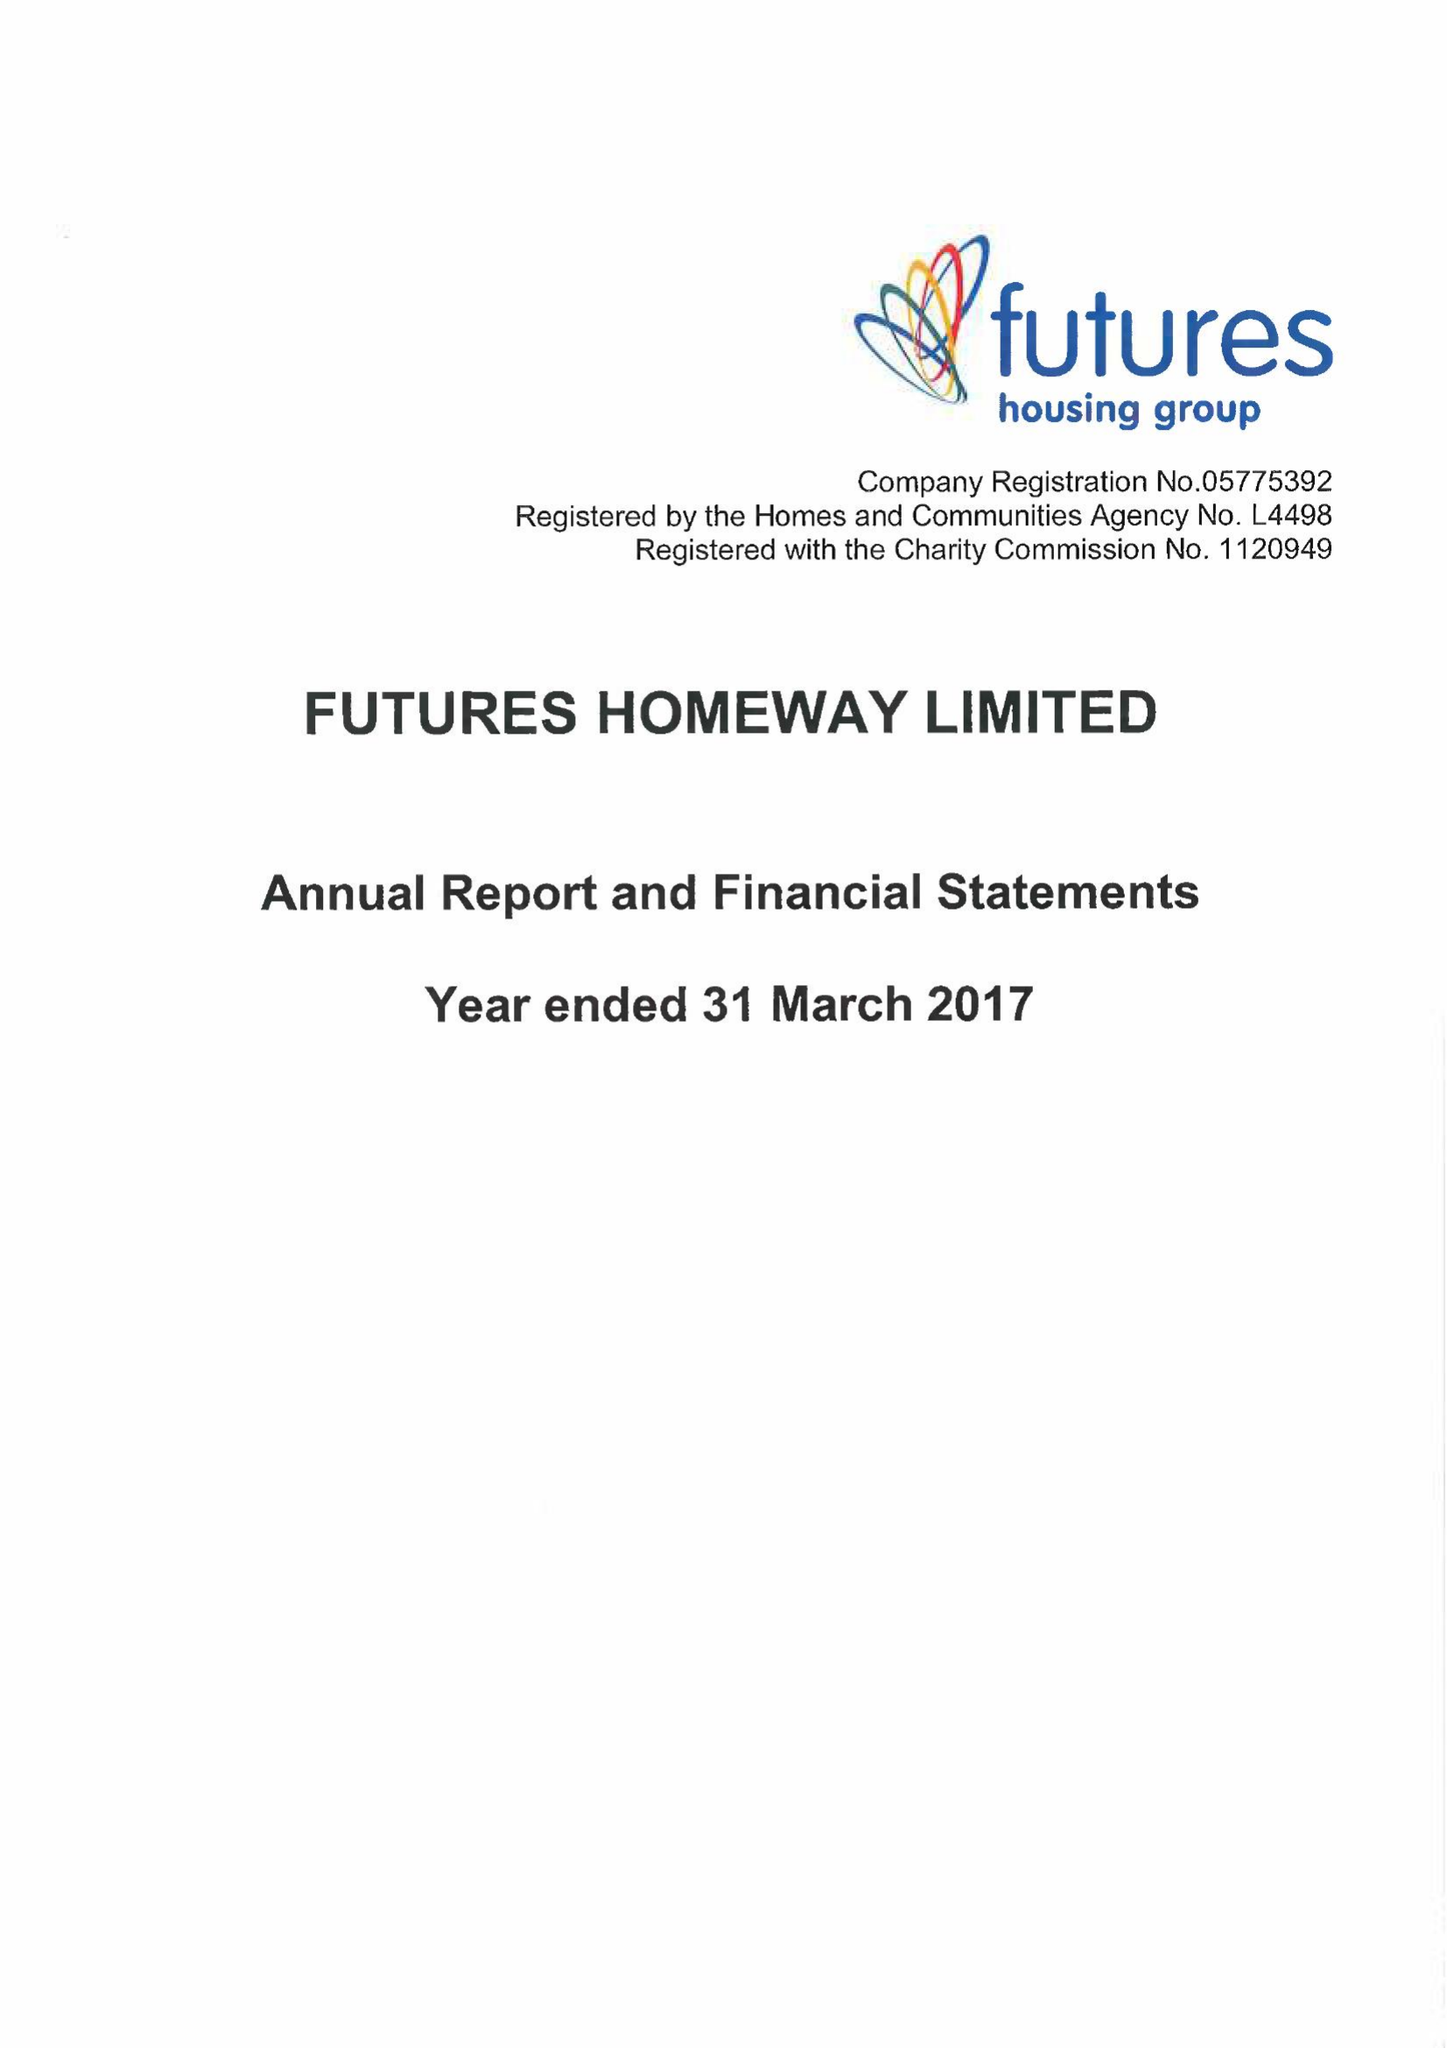What is the value for the income_annually_in_british_pounds?
Answer the question using a single word or phrase. 17701000.00 